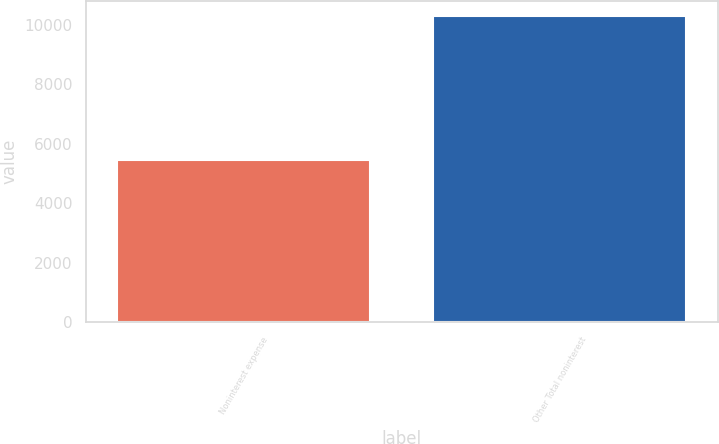<chart> <loc_0><loc_0><loc_500><loc_500><bar_chart><fcel>Noninterest expense<fcel>Other Total noninterest<nl><fcel>5471<fcel>10296<nl></chart> 